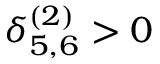Convert formula to latex. <formula><loc_0><loc_0><loc_500><loc_500>\delta _ { 5 , 6 } ^ { ( 2 ) } > 0</formula> 